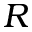Convert formula to latex. <formula><loc_0><loc_0><loc_500><loc_500>R</formula> 